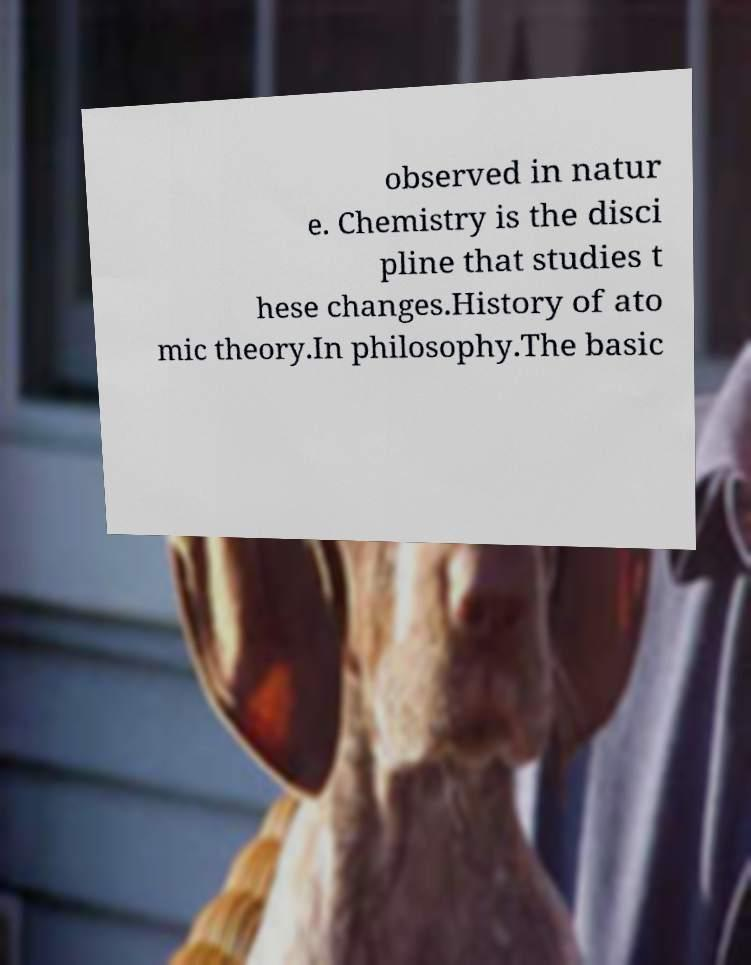There's text embedded in this image that I need extracted. Can you transcribe it verbatim? observed in natur e. Chemistry is the disci pline that studies t hese changes.History of ato mic theory.In philosophy.The basic 